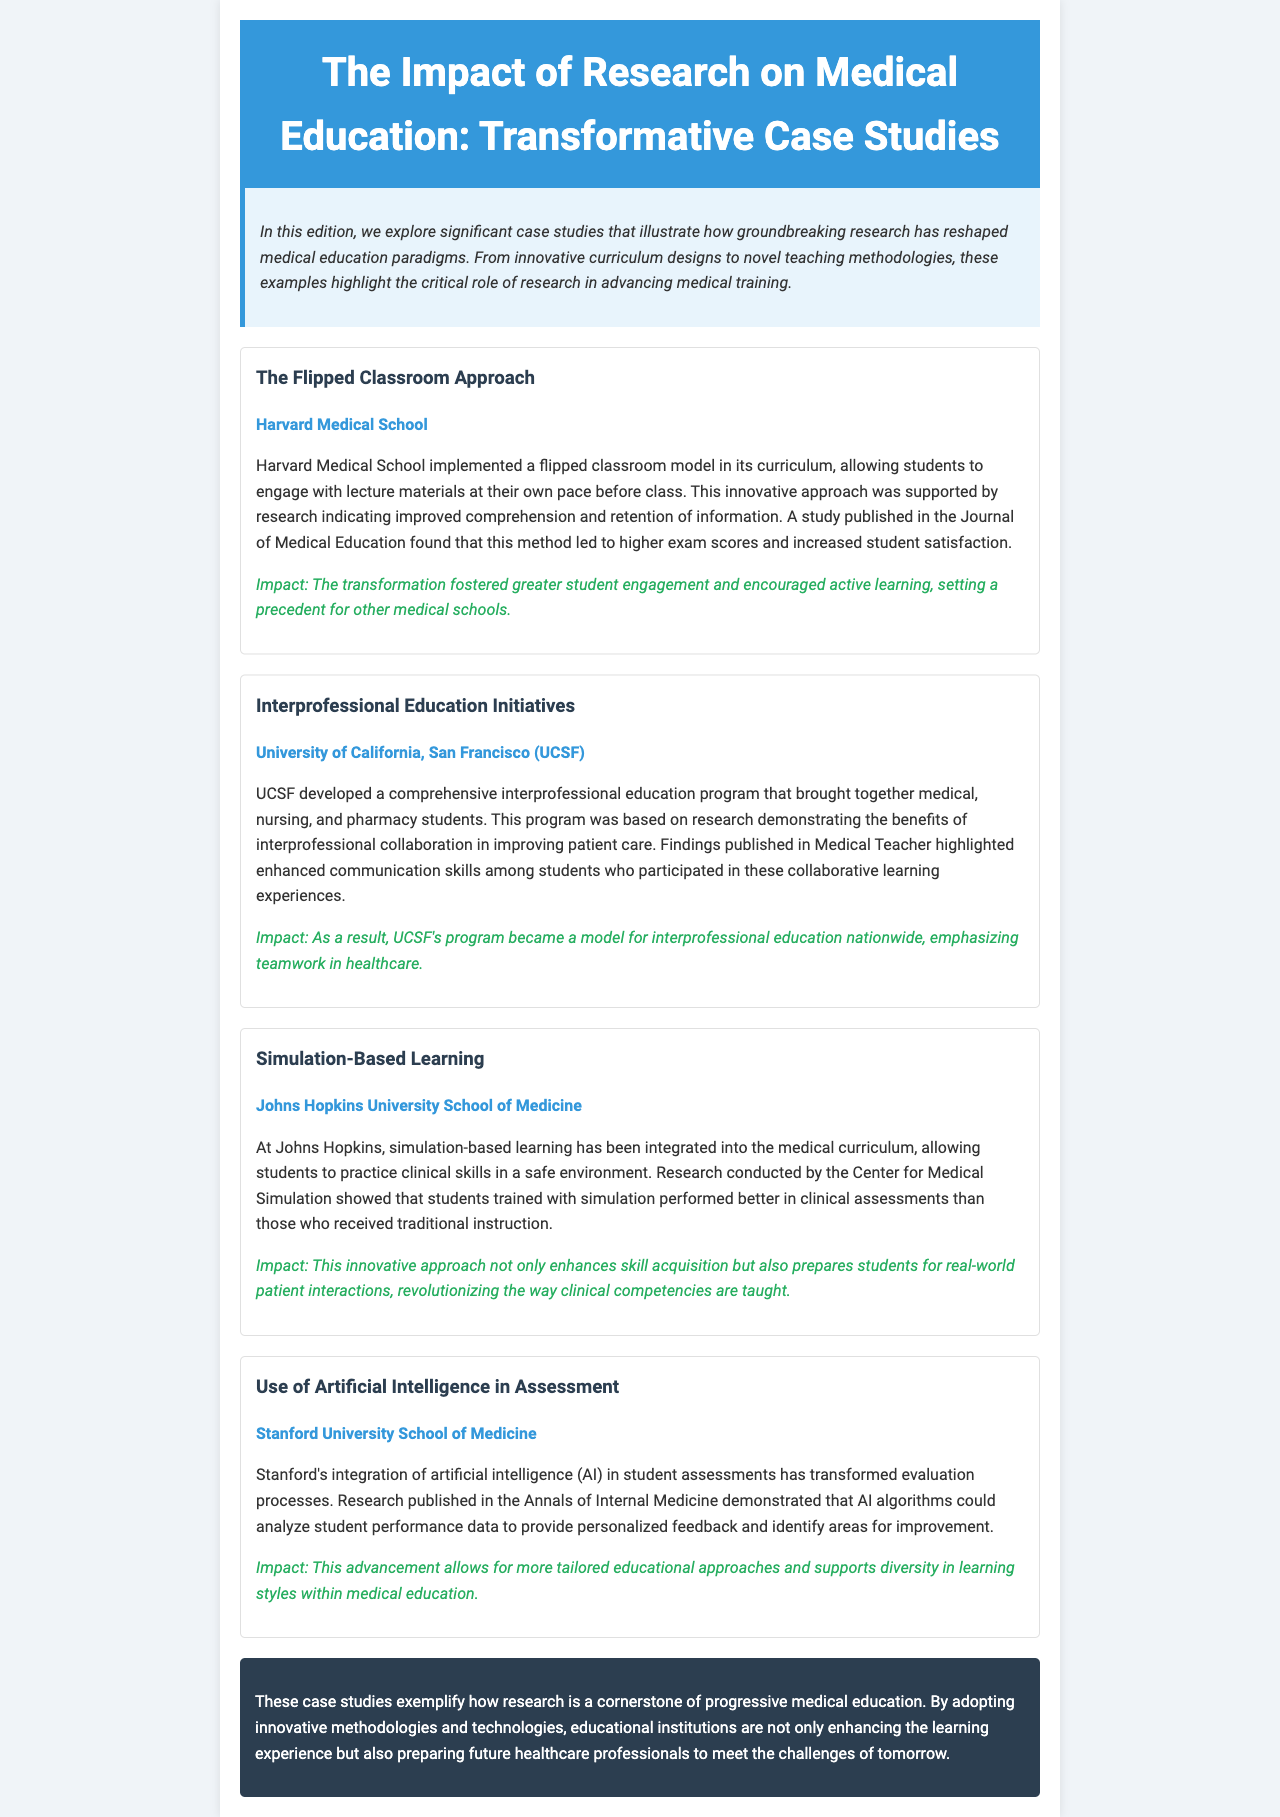what is the title of the newsletter? The title is found in the header section of the document, which reads "The Impact of Research on Medical Education: Transformative Case Studies."
Answer: The Impact of Research on Medical Education: Transformative Case Studies which institution implemented the flipped classroom approach? The institution is specifically mentioned in the case study titled "The Flipped Classroom Approach."
Answer: Harvard Medical School how many case studies are highlighted in the newsletter? The number of case studies is indicated in the case studies section, and there are four examples provided.
Answer: Four what educational model is discussed in the second case study? The educational model is referenced in the case study titled "Interprofessional Education Initiatives," which emphasizes collaboration.
Answer: Interprofessional education which university's program became a model for interprofessional education nationwide? The specific institution is noted in the impact statement of the second case study.
Answer: University of California, San Francisco what technology is used in Stanford University's assessment methods? The technology mentioned in the document specifically in the context of Stanford's methods is described in the fourth case study.
Answer: Artificial intelligence what was the impact of simulation-based learning according to the newsletter? The impact is highlighted in the related case study, summarizing the benefits derived from simulation training.
Answer: Enhances skill acquisition what challenge does research help address in medical education? The document concludes with a statement regarding the challenges in medical education that research seeks to overcome.
Answer: Challenges of tomorrow 